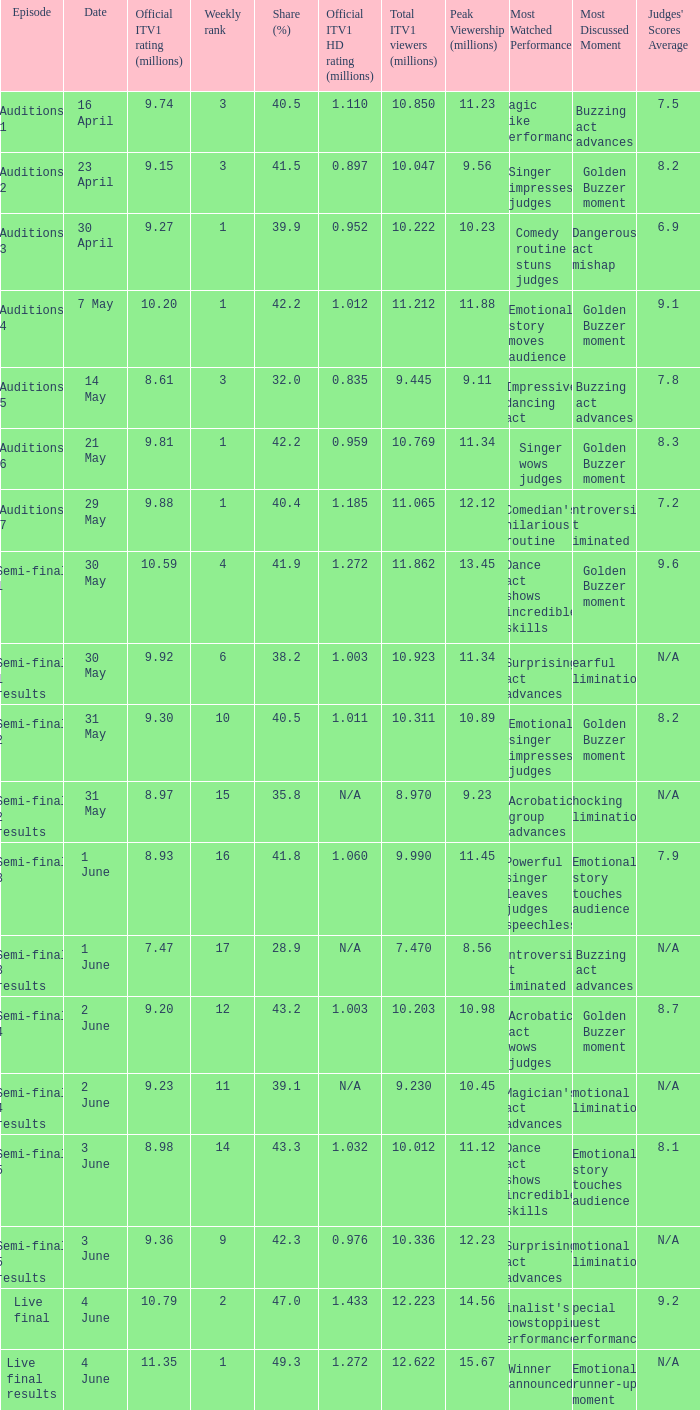What was the total ITV1 viewers in millions for the episode with a share (%) of 28.9?  7.47. 